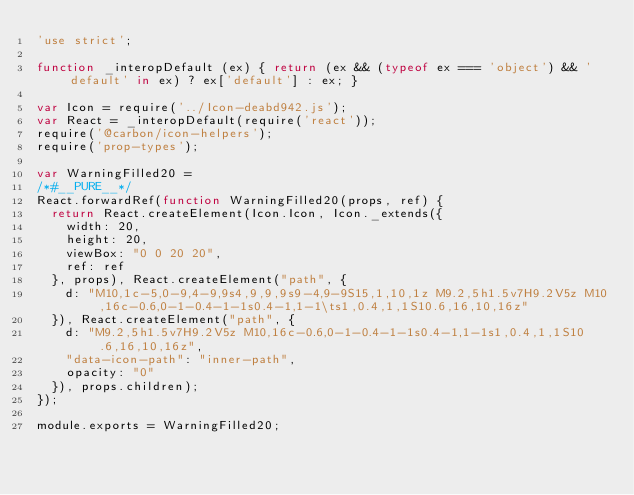<code> <loc_0><loc_0><loc_500><loc_500><_JavaScript_>'use strict';

function _interopDefault (ex) { return (ex && (typeof ex === 'object') && 'default' in ex) ? ex['default'] : ex; }

var Icon = require('../Icon-deabd942.js');
var React = _interopDefault(require('react'));
require('@carbon/icon-helpers');
require('prop-types');

var WarningFilled20 =
/*#__PURE__*/
React.forwardRef(function WarningFilled20(props, ref) {
  return React.createElement(Icon.Icon, Icon._extends({
    width: 20,
    height: 20,
    viewBox: "0 0 20 20",
    ref: ref
  }, props), React.createElement("path", {
    d: "M10,1c-5,0-9,4-9,9s4,9,9,9s9-4,9-9S15,1,10,1z M9.2,5h1.5v7H9.2V5z M10,16c-0.6,0-1-0.4-1-1s0.4-1,1-1\ts1,0.4,1,1S10.6,16,10,16z"
  }), React.createElement("path", {
    d: "M9.2,5h1.5v7H9.2V5z M10,16c-0.6,0-1-0.4-1-1s0.4-1,1-1s1,0.4,1,1S10.6,16,10,16z",
    "data-icon-path": "inner-path",
    opacity: "0"
  }), props.children);
});

module.exports = WarningFilled20;
</code> 